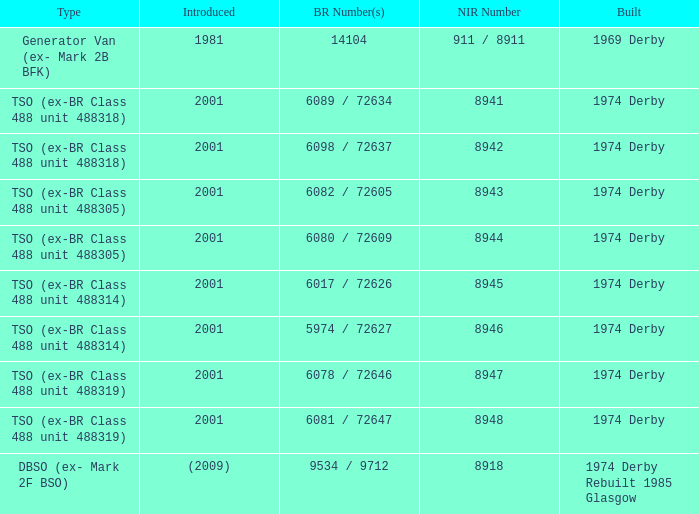Which NIR number is for the tso (ex-br class 488 unit 488305) type that has a 6082 / 72605 BR number? 8943.0. 